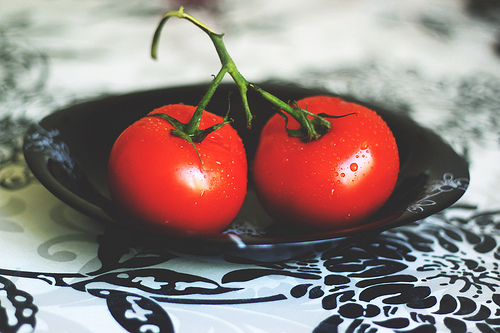<image>
Is the tomato on the table? No. The tomato is not positioned on the table. They may be near each other, but the tomato is not supported by or resting on top of the table. Is there a tablecloth under the tomatos? Yes. The tablecloth is positioned underneath the tomatos, with the tomatos above it in the vertical space. Where is the plate in relation to the tomato? Is it behind the tomato? No. The plate is not behind the tomato. From this viewpoint, the plate appears to be positioned elsewhere in the scene. Is there a tomato in the tablecloth? No. The tomato is not contained within the tablecloth. These objects have a different spatial relationship. Is the tomato in front of the tomato? No. The tomato is not in front of the tomato. The spatial positioning shows a different relationship between these objects. 